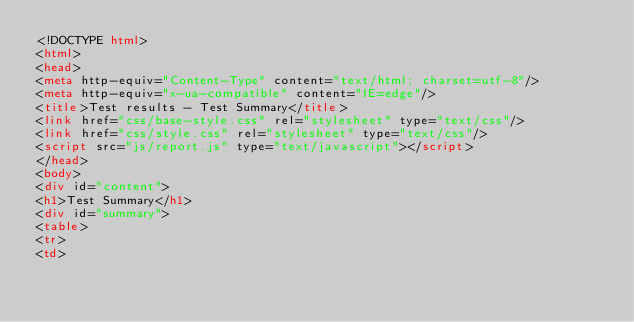Convert code to text. <code><loc_0><loc_0><loc_500><loc_500><_HTML_><!DOCTYPE html>
<html>
<head>
<meta http-equiv="Content-Type" content="text/html; charset=utf-8"/>
<meta http-equiv="x-ua-compatible" content="IE=edge"/>
<title>Test results - Test Summary</title>
<link href="css/base-style.css" rel="stylesheet" type="text/css"/>
<link href="css/style.css" rel="stylesheet" type="text/css"/>
<script src="js/report.js" type="text/javascript"></script>
</head>
<body>
<div id="content">
<h1>Test Summary</h1>
<div id="summary">
<table>
<tr>
<td></code> 